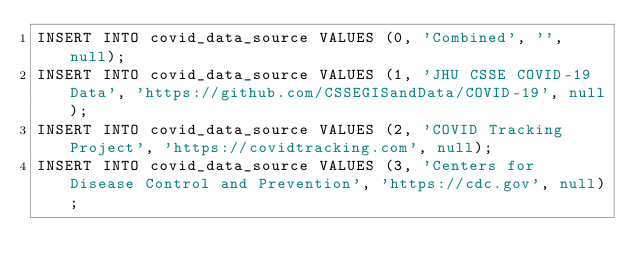<code> <loc_0><loc_0><loc_500><loc_500><_SQL_>INSERT INTO covid_data_source VALUES (0, 'Combined', '', null);
INSERT INTO covid_data_source VALUES (1, 'JHU CSSE COVID-19 Data', 'https://github.com/CSSEGISandData/COVID-19', null);
INSERT INTO covid_data_source VALUES (2, 'COVID Tracking Project', 'https://covidtracking.com', null);
INSERT INTO covid_data_source VALUES (3, 'Centers for Disease Control and Prevention', 'https://cdc.gov', null);
</code> 